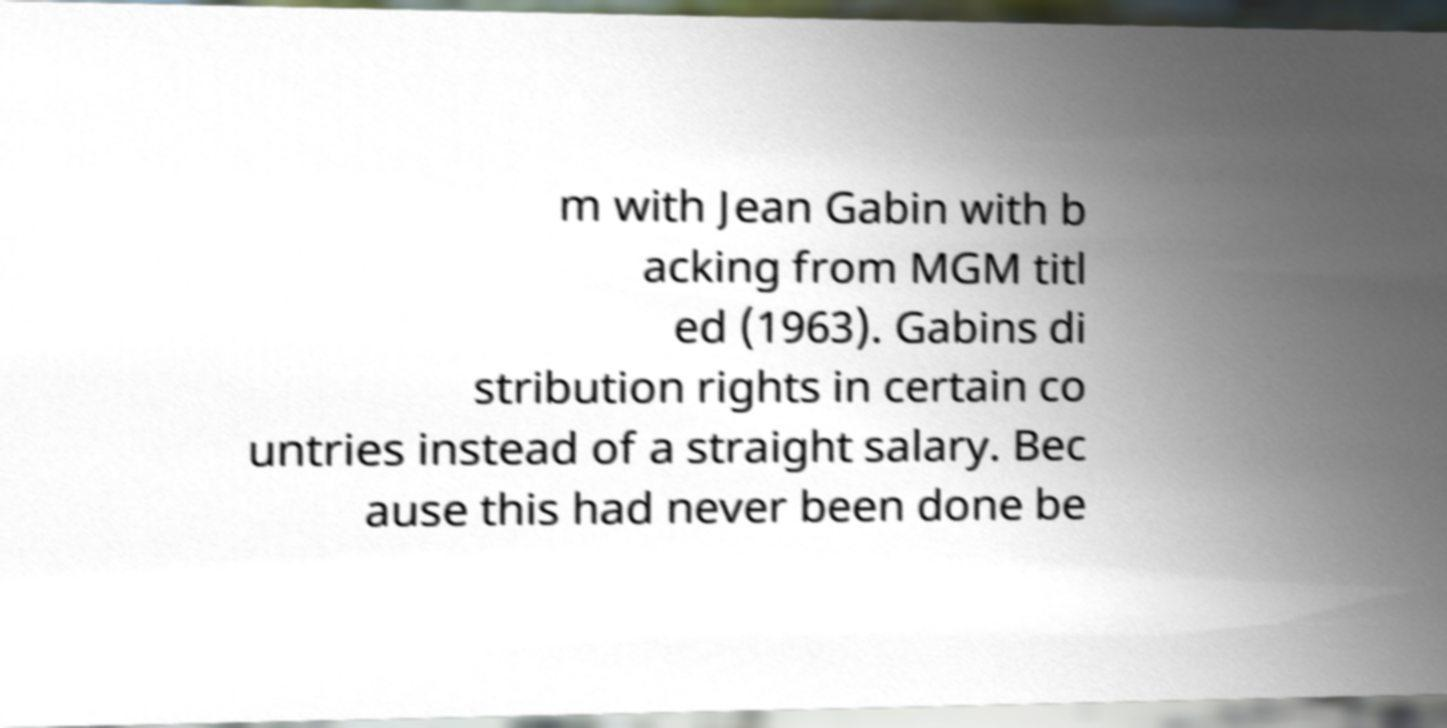There's text embedded in this image that I need extracted. Can you transcribe it verbatim? m with Jean Gabin with b acking from MGM titl ed (1963). Gabins di stribution rights in certain co untries instead of a straight salary. Bec ause this had never been done be 